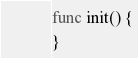Convert code to text. <code><loc_0><loc_0><loc_500><loc_500><_Go_>
func init() {
}
</code> 